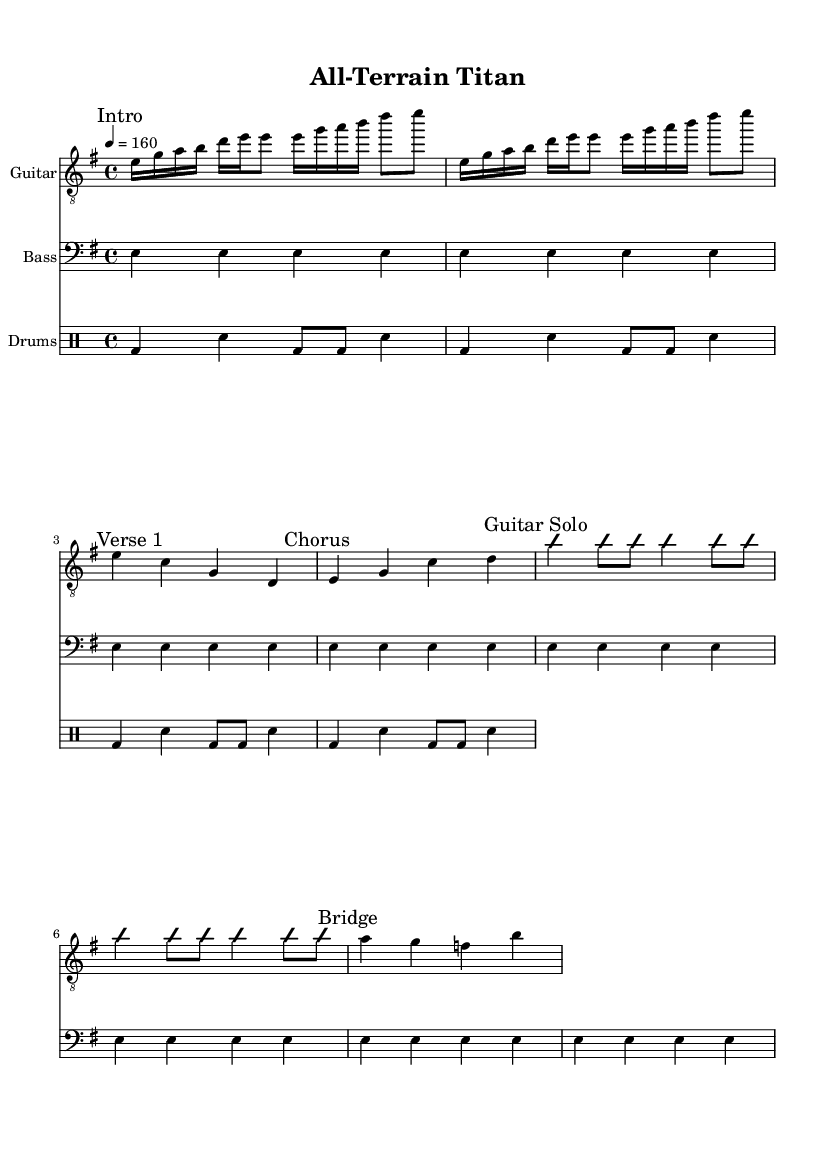What is the key signature of this music? The key signature is indicated at the beginning of the sheet music, showing a single sharp, which corresponds to E minor.
Answer: E minor What is the time signature of this music? The time signature is found at the beginning of the score, displaying four beats per measure, indicated by 4/4.
Answer: 4/4 What is the tempo marking for this piece? The tempo marking is given in beats per minute, specifically stating "4 = 160," which indicates the speed of the piece.
Answer: 160 How many measures are in the guitar part before the guitar solo? By counting the measures, the guitar part has a total of seven measures before the guitar solo starts.
Answer: 7 What is the main theme of the "Chorus"? The "Chorus" is comprised of the notes E, G, C, and D played in succession, which serves as the melodic highlight.
Answer: E, G, C, D How many times is the bass part repeated? The bass part is repeated eight times as indicated in the score, which is a common technique in rock music to establish a groove.
Answer: 8 What instrument plays the basic rock beat? The basic rock beat is played by the drums, as indicated in the drum staff of the score.
Answer: Drums 